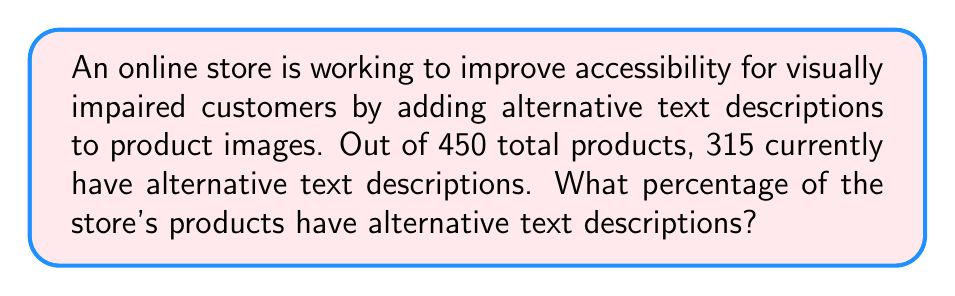Can you solve this math problem? To calculate the percentage of products with alternative text descriptions, we need to use the following formula:

$$ \text{Percentage} = \frac{\text{Number of products with alt text}}{\text{Total number of products}} \times 100\% $$

Given:
- Total number of products: 450
- Number of products with alternative text descriptions: 315

Let's substitute these values into the formula:

$$ \text{Percentage} = \frac{315}{450} \times 100\% $$

To simplify this fraction, we can divide both the numerator and denominator by their greatest common divisor (GCD). The GCD of 315 and 450 is 45.

$$ \text{Percentage} = \frac{315 \div 45}{450 \div 45} \times 100\% = \frac{7}{10} \times 100\% $$

Now, we can perform the multiplication:

$$ \text{Percentage} = 0.7 \times 100\% = 70\% $$

Therefore, 70% of the store's products have alternative text descriptions.
Answer: 70% 